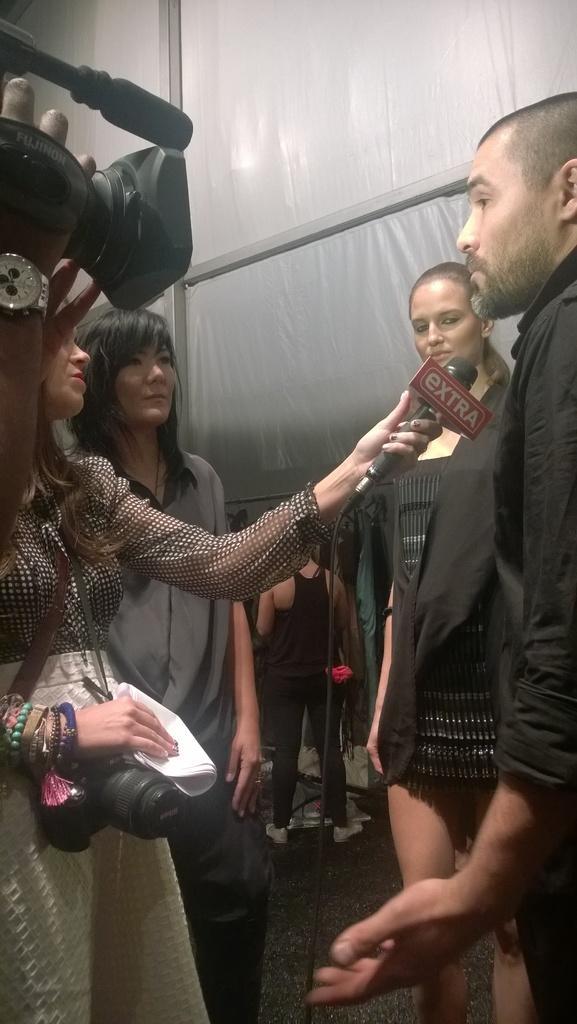Please provide a concise description of this image. In this image we can see three women and one man. One woman is holding a mic in her hand. In the background, we can see people and a white color sheet with metal rods. On the left side of the image, we can see a human hand holding a camera. 